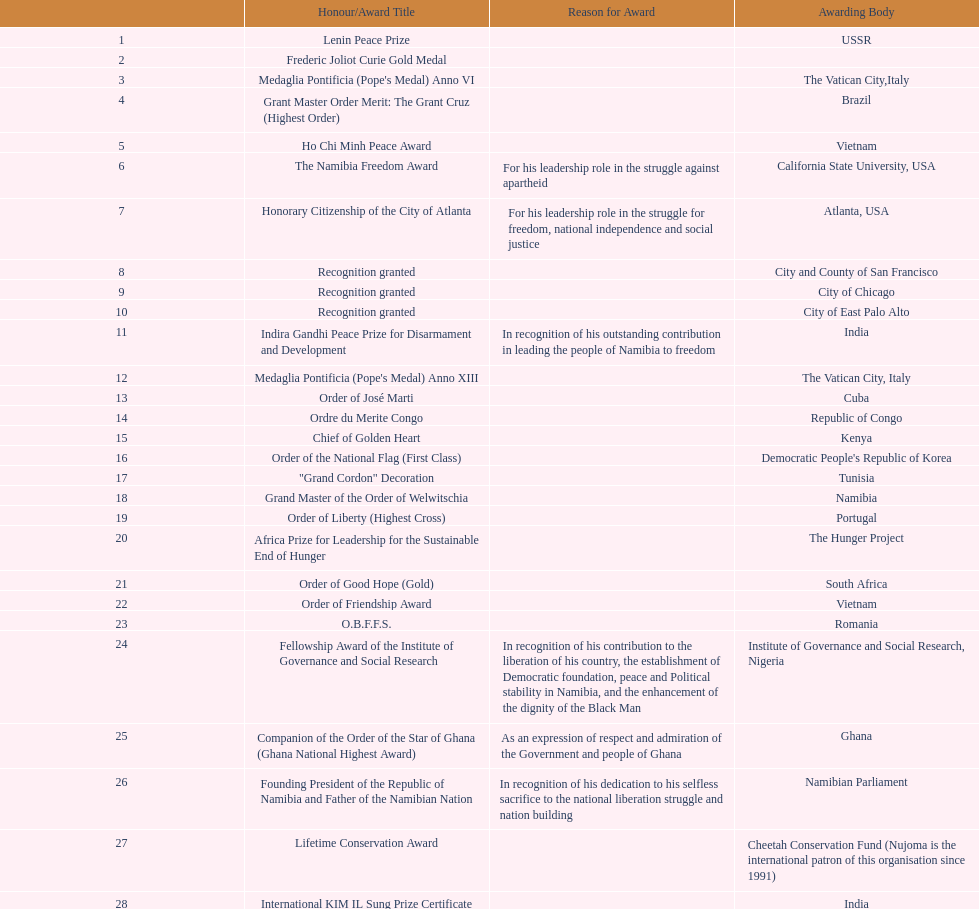What award was won previously just before the medaglia pontificia anno xiii was awarded? Indira Gandhi Peace Prize for Disarmament and Development. 